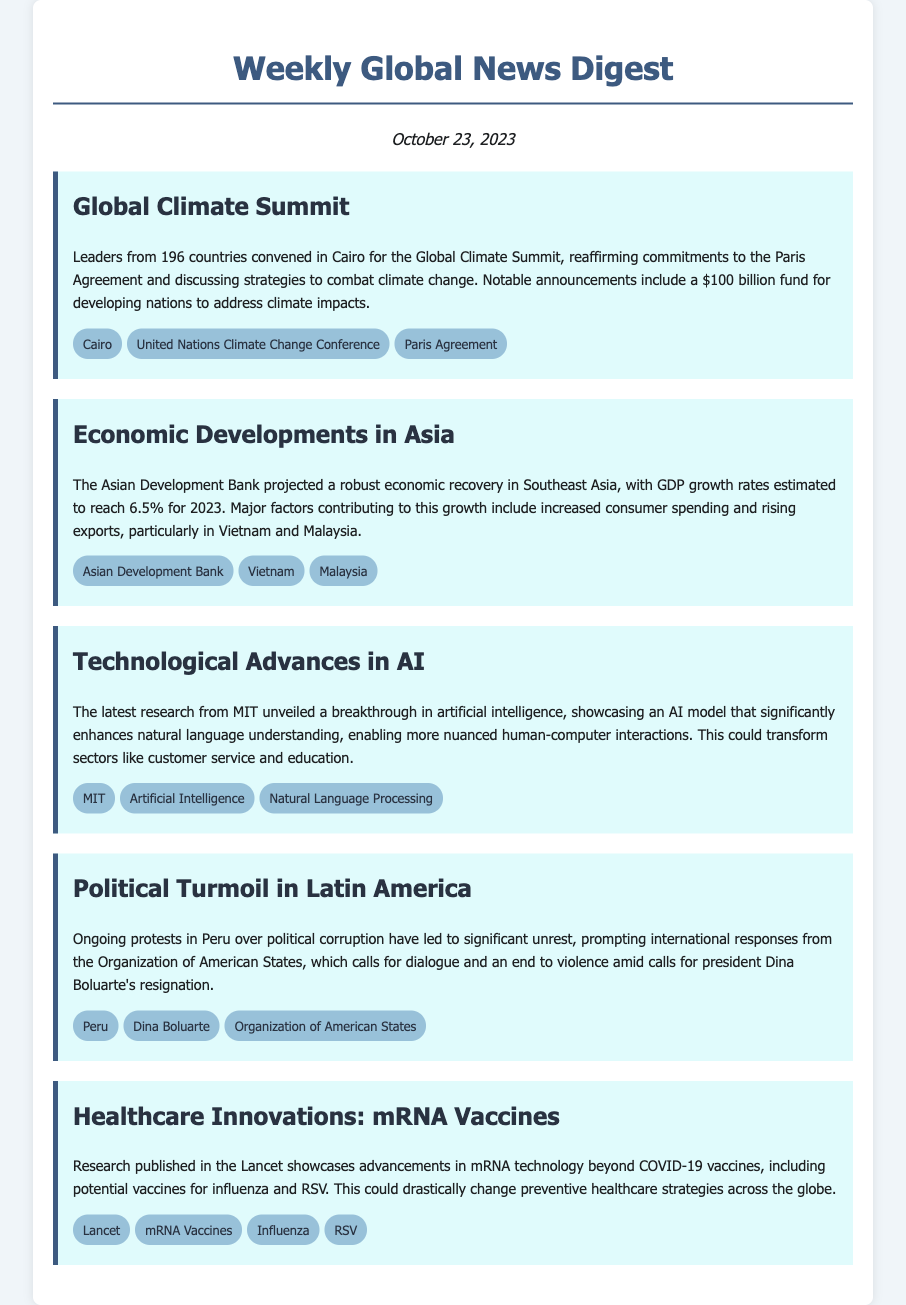What city hosted the Global Climate Summit? The document states that leaders convened in Cairo for the Global Climate Summit.
Answer: Cairo What is the GDP growth rate projected for Southeast Asia in 2023? The Asian Development Bank estimates that GDP growth rates will reach 6.5% for 2023.
Answer: 6.5% Which institution unveiled a breakthrough in artificial intelligence? The document mentions that MIT unveiled the breakthrough in artificial intelligence.
Answer: MIT What is the name of the president facing calls for resignation in Peru? The document identifies Dina Boluarte as the president facing calls for resignation.
Answer: Dina Boluarte What technology is being researched for potential vaccines beyond COVID-19? The document discusses advancements in mRNA technology for potential vaccines.
Answer: mRNA Vaccines How many countries participated in the Global Climate Summit? The document states that leaders from 196 countries convened for the Global Climate Summit.
Answer: 196 What was a major factor contributing to economic recovery in Southeast Asia? Increased consumer spending is listed as a major factor contributing to economic recovery.
Answer: Increased consumer spending Which publication featured research on mRNA vaccines? The document notes that research on mRNA vaccines was published in the Lancet.
Answer: Lancet What international organization called for dialogue in response to protests in Peru? The Organization of American States is mentioned as calling for dialogue.
Answer: Organization of American States 